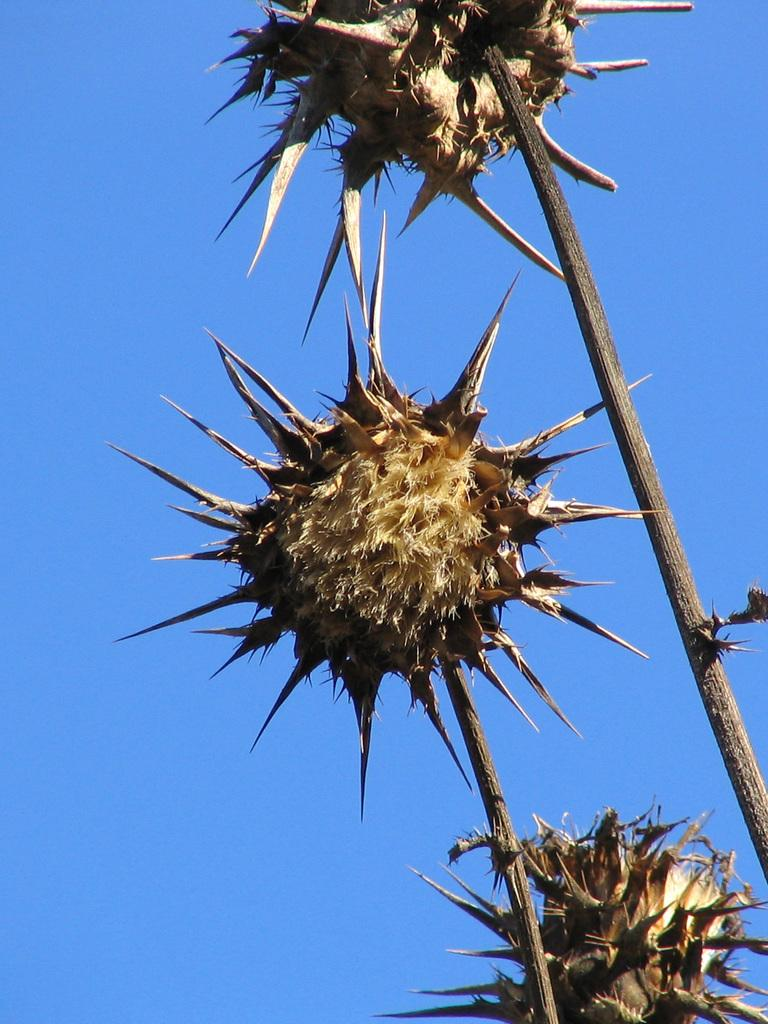What is the main object in the image? There is a stem in the image. What is attached to the stem? There are dried fruits attached to the stem. What can be seen in the background of the image? The sky is visible in the background of the image. What type of button can be seen on the stem in the image? There is no button present on the stem in the image. Is there anyone reading a book in the image? There is no indication of anyone reading a book in the image. 